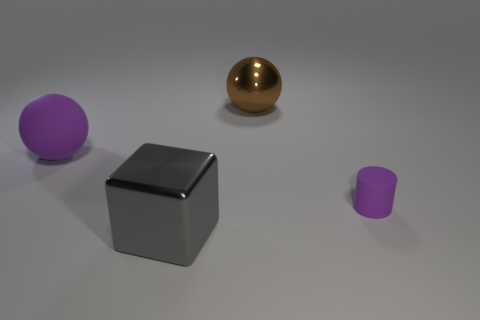Add 2 small purple rubber cylinders. How many objects exist? 6 Subtract all cubes. How many objects are left? 3 Subtract all large yellow cylinders. Subtract all brown spheres. How many objects are left? 3 Add 2 purple cylinders. How many purple cylinders are left? 3 Add 3 small red metal things. How many small red metal things exist? 3 Subtract 0 green cylinders. How many objects are left? 4 